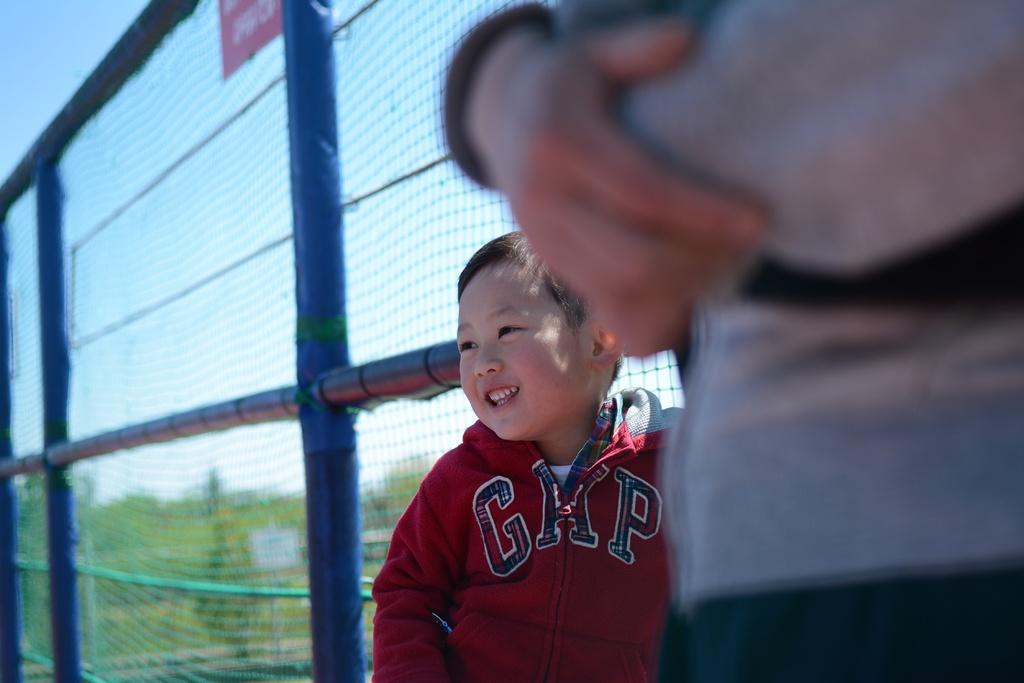<image>
Provide a brief description of the given image. a little boy wearing a jacket that says 'gap' 